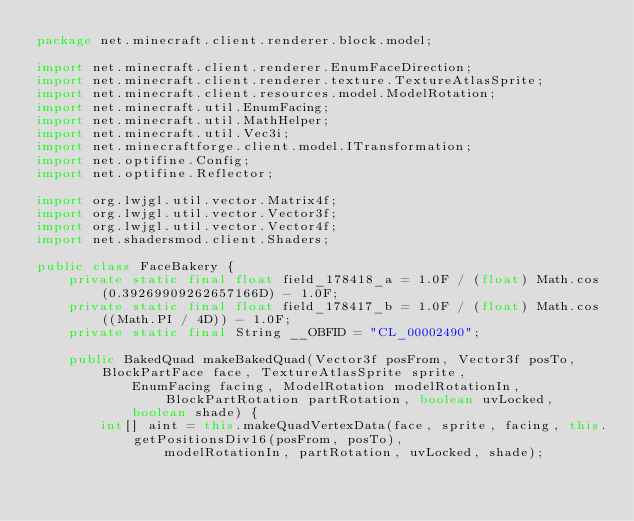<code> <loc_0><loc_0><loc_500><loc_500><_Java_>package net.minecraft.client.renderer.block.model;

import net.minecraft.client.renderer.EnumFaceDirection;
import net.minecraft.client.renderer.texture.TextureAtlasSprite;
import net.minecraft.client.resources.model.ModelRotation;
import net.minecraft.util.EnumFacing;
import net.minecraft.util.MathHelper;
import net.minecraft.util.Vec3i;
import net.minecraftforge.client.model.ITransformation;
import net.optifine.Config;
import net.optifine.Reflector;

import org.lwjgl.util.vector.Matrix4f;
import org.lwjgl.util.vector.Vector3f;
import org.lwjgl.util.vector.Vector4f;
import net.shadersmod.client.Shaders;

public class FaceBakery {
	private static final float field_178418_a = 1.0F / (float) Math.cos(0.39269909262657166D) - 1.0F;
	private static final float field_178417_b = 1.0F / (float) Math.cos((Math.PI / 4D)) - 1.0F;
	private static final String __OBFID = "CL_00002490";

	public BakedQuad makeBakedQuad(Vector3f posFrom, Vector3f posTo, BlockPartFace face, TextureAtlasSprite sprite,
			EnumFacing facing, ModelRotation modelRotationIn, BlockPartRotation partRotation, boolean uvLocked,
			boolean shade) {
		int[] aint = this.makeQuadVertexData(face, sprite, facing, this.getPositionsDiv16(posFrom, posTo),
				modelRotationIn, partRotation, uvLocked, shade);</code> 